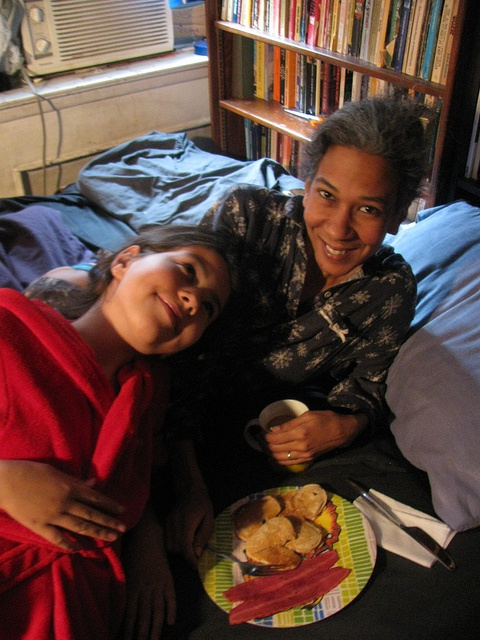Describe the objects in this image and their specific colors. I can see people in gray, black, maroon, and brown tones, people in gray, black, maroon, and brown tones, bed in gray and black tones, book in gray, tan, and maroon tones, and book in gray, black, and maroon tones in this image. 